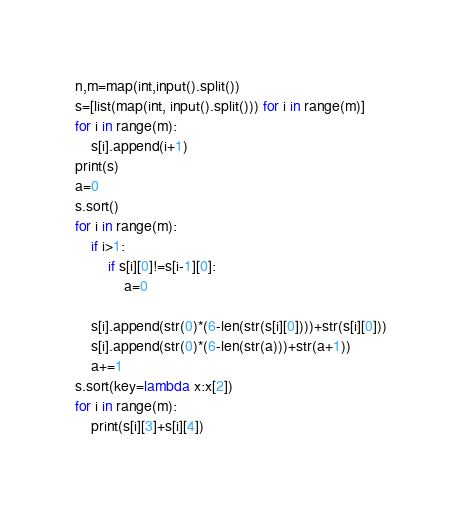Convert code to text. <code><loc_0><loc_0><loc_500><loc_500><_Python_>n,m=map(int,input().split())
s=[list(map(int, input().split())) for i in range(m)] 
for i in range(m):
    s[i].append(i+1)
print(s)
a=0
s.sort()
for i in range(m):
    if i>1:
        if s[i][0]!=s[i-1][0]:
            a=0
        
    s[i].append(str(0)*(6-len(str(s[i][0])))+str(s[i][0]))
    s[i].append(str(0)*(6-len(str(a)))+str(a+1))
    a+=1
s.sort(key=lambda x:x[2])
for i in range(m):
    print(s[i][3]+s[i][4])</code> 